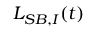<formula> <loc_0><loc_0><loc_500><loc_500>{ { L } _ { S B , I } } ( t )</formula> 